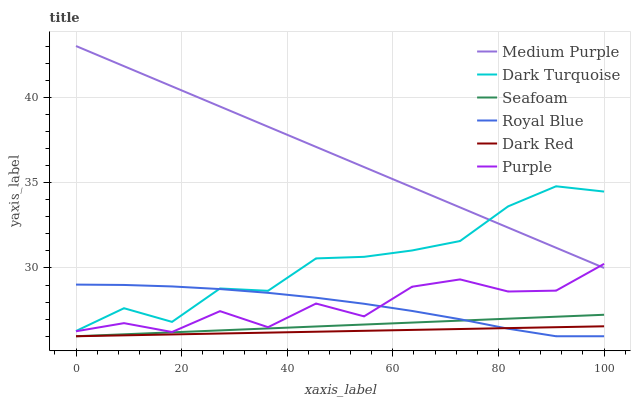Does Dark Red have the minimum area under the curve?
Answer yes or no. Yes. Does Medium Purple have the maximum area under the curve?
Answer yes or no. Yes. Does Dark Turquoise have the minimum area under the curve?
Answer yes or no. No. Does Dark Turquoise have the maximum area under the curve?
Answer yes or no. No. Is Dark Red the smoothest?
Answer yes or no. Yes. Is Purple the roughest?
Answer yes or no. Yes. Is Dark Turquoise the smoothest?
Answer yes or no. No. Is Dark Turquoise the roughest?
Answer yes or no. No. Does Dark Turquoise have the lowest value?
Answer yes or no. No. Does Dark Turquoise have the highest value?
Answer yes or no. No. Is Dark Red less than Medium Purple?
Answer yes or no. Yes. Is Medium Purple greater than Royal Blue?
Answer yes or no. Yes. Does Dark Red intersect Medium Purple?
Answer yes or no. No. 